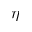Convert formula to latex. <formula><loc_0><loc_0><loc_500><loc_500>\eta</formula> 